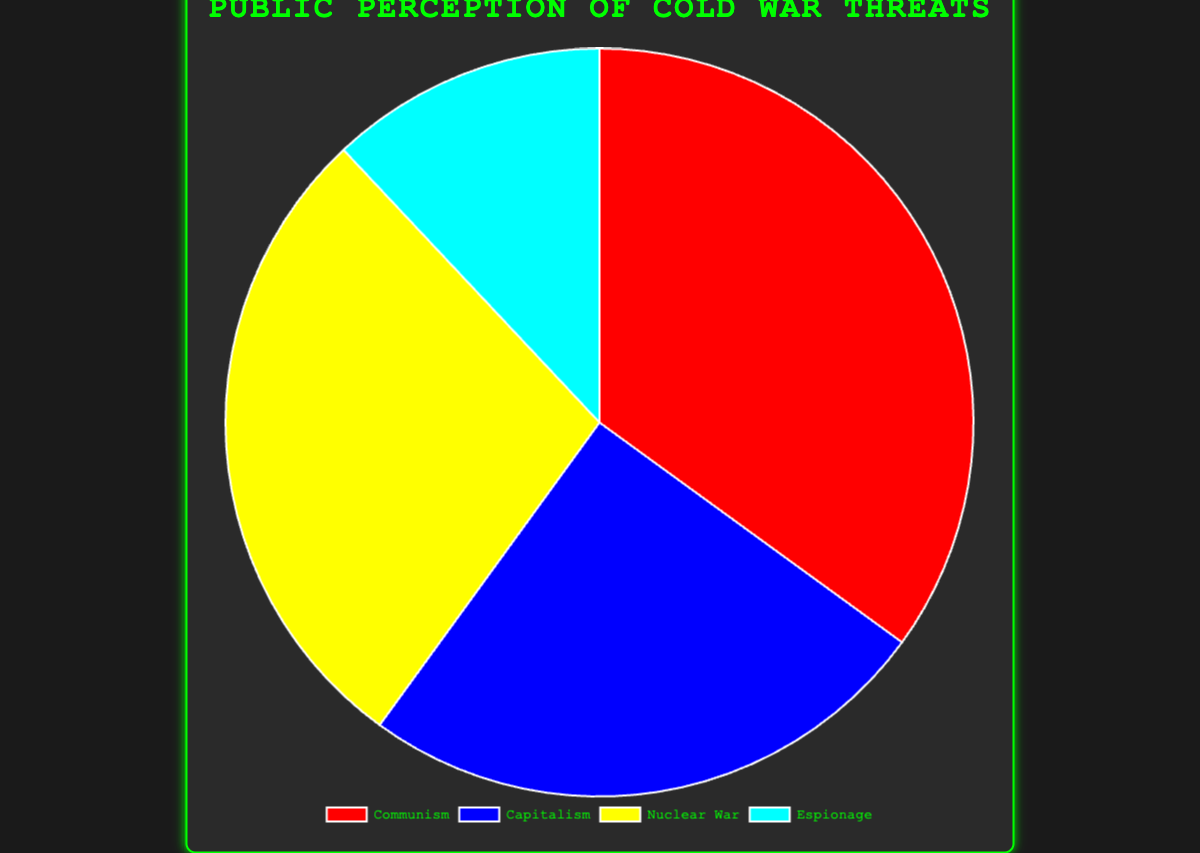Which ideological threat was perceived as the greatest during the Cold War? By looking at the data, the largest sector in the pie chart represents the most significant perceived threat. The sector for Communism has the largest portion at 35%.
Answer: Communism How much greater is the perception percentage of Communism compared to Espionage? The perception percentage of Communism is 35%, and Espionage is 12%. The difference between them is 35% - 12% = 23%
Answer: 23% Which threat is perceived as the least significant and what is its percentage? The smallest sector in the pie chart represents the least significant threat. That would be Espionage, which comprises 12% of the chart.
Answer: Espionage, 12% What is the combined perception percentage of Capitalism and Nuclear War? To find the combined percentage, add the values for Capitalism (25%) and Nuclear War (28%). 25% + 28% = 53%
Answer: 53% Is the perception of Nuclear War greater than the perception of Capitalism? By comparing the two values, Nuclear War (28%) and Capitalism (25%), we see that 28% is greater than 25%.
Answer: Yes How much smaller is the perception percentage of Capitalism compared to Communism? The perception percentage of Communism is 35%, and Capitalism is 25%. The difference is 35% - 25% = 10%
Answer: 10% Which section of the pie chart is represented by a yellow color? The pie chart has distinct colors for each threat. Yellow is used to represent Nuclear War in the chart.
Answer: Nuclear War What is the total percentage of all ideological threats combined? Add up all the given perceptions: 35% (Communism) + 25% (Capitalism) + 28% (Nuclear War) + 12% (Espionage) = 100%
Answer: 100% What is the average perception percentage of all four threats? Calculate the sum of all perception percentages and divide by the number of threats: (35% + 25% + 28% + 12%) / 4 = 25%
Answer: 25% Does any threat have a perception percentage equal to or greater than 30%? The only threat with a perception percentage equal to or greater than 30% is Communism, which has 35%. None of the other threats reach this level.
Answer: Communism, 35% 